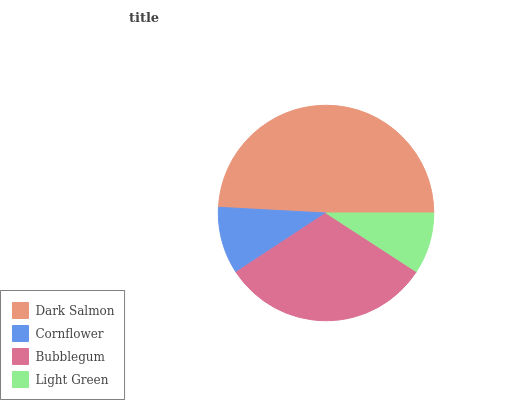Is Light Green the minimum?
Answer yes or no. Yes. Is Dark Salmon the maximum?
Answer yes or no. Yes. Is Cornflower the minimum?
Answer yes or no. No. Is Cornflower the maximum?
Answer yes or no. No. Is Dark Salmon greater than Cornflower?
Answer yes or no. Yes. Is Cornflower less than Dark Salmon?
Answer yes or no. Yes. Is Cornflower greater than Dark Salmon?
Answer yes or no. No. Is Dark Salmon less than Cornflower?
Answer yes or no. No. Is Bubblegum the high median?
Answer yes or no. Yes. Is Cornflower the low median?
Answer yes or no. Yes. Is Dark Salmon the high median?
Answer yes or no. No. Is Light Green the low median?
Answer yes or no. No. 